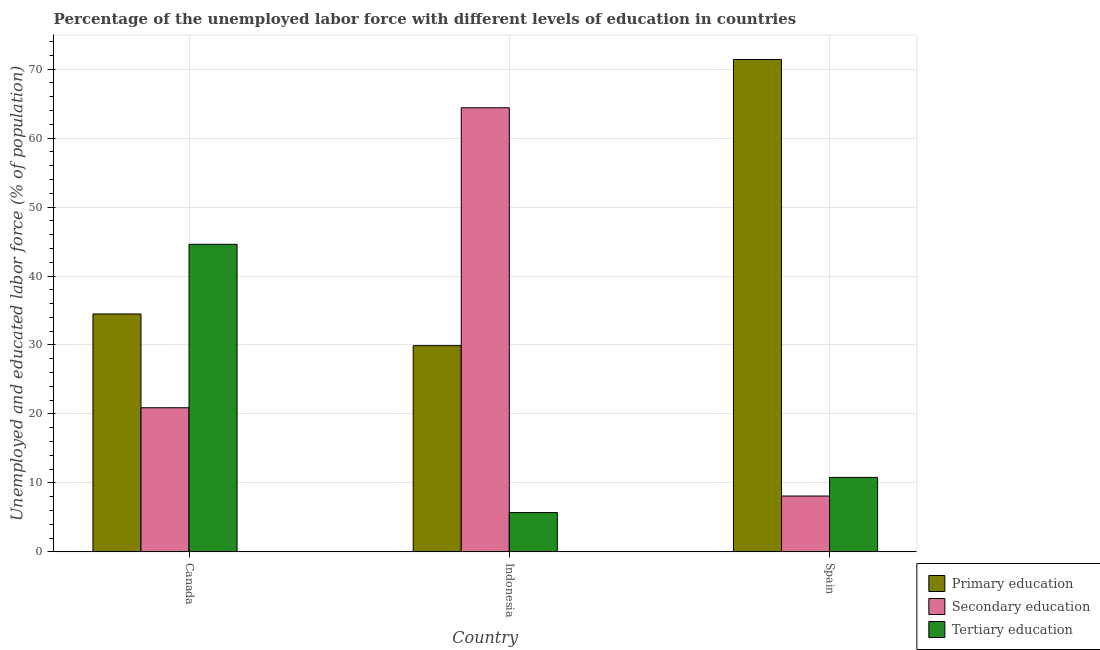How many different coloured bars are there?
Keep it short and to the point. 3. How many groups of bars are there?
Offer a terse response. 3. Are the number of bars on each tick of the X-axis equal?
Ensure brevity in your answer.  Yes. How many bars are there on the 1st tick from the left?
Offer a very short reply. 3. How many bars are there on the 1st tick from the right?
Ensure brevity in your answer.  3. What is the label of the 2nd group of bars from the left?
Provide a short and direct response. Indonesia. What is the percentage of labor force who received tertiary education in Canada?
Keep it short and to the point. 44.6. Across all countries, what is the maximum percentage of labor force who received tertiary education?
Ensure brevity in your answer.  44.6. Across all countries, what is the minimum percentage of labor force who received tertiary education?
Make the answer very short. 5.7. What is the total percentage of labor force who received secondary education in the graph?
Your answer should be very brief. 93.4. What is the difference between the percentage of labor force who received secondary education in Canada and that in Spain?
Your response must be concise. 12.8. What is the difference between the percentage of labor force who received secondary education in Canada and the percentage of labor force who received tertiary education in Indonesia?
Your answer should be very brief. 15.2. What is the average percentage of labor force who received secondary education per country?
Provide a succinct answer. 31.13. What is the difference between the percentage of labor force who received primary education and percentage of labor force who received tertiary education in Indonesia?
Keep it short and to the point. 24.2. In how many countries, is the percentage of labor force who received primary education greater than 36 %?
Your answer should be compact. 1. What is the ratio of the percentage of labor force who received tertiary education in Indonesia to that in Spain?
Your response must be concise. 0.53. Is the difference between the percentage of labor force who received secondary education in Canada and Indonesia greater than the difference between the percentage of labor force who received primary education in Canada and Indonesia?
Offer a terse response. No. What is the difference between the highest and the second highest percentage of labor force who received tertiary education?
Keep it short and to the point. 33.8. What is the difference between the highest and the lowest percentage of labor force who received secondary education?
Your answer should be compact. 56.3. Is the sum of the percentage of labor force who received secondary education in Canada and Spain greater than the maximum percentage of labor force who received tertiary education across all countries?
Offer a terse response. No. What does the 3rd bar from the left in Canada represents?
Provide a short and direct response. Tertiary education. What does the 1st bar from the right in Spain represents?
Offer a very short reply. Tertiary education. How many countries are there in the graph?
Your answer should be compact. 3. Does the graph contain any zero values?
Your answer should be very brief. No. Where does the legend appear in the graph?
Keep it short and to the point. Bottom right. What is the title of the graph?
Your answer should be compact. Percentage of the unemployed labor force with different levels of education in countries. Does "Maunufacturing" appear as one of the legend labels in the graph?
Give a very brief answer. No. What is the label or title of the X-axis?
Your response must be concise. Country. What is the label or title of the Y-axis?
Your answer should be very brief. Unemployed and educated labor force (% of population). What is the Unemployed and educated labor force (% of population) of Primary education in Canada?
Provide a short and direct response. 34.5. What is the Unemployed and educated labor force (% of population) of Secondary education in Canada?
Give a very brief answer. 20.9. What is the Unemployed and educated labor force (% of population) in Tertiary education in Canada?
Make the answer very short. 44.6. What is the Unemployed and educated labor force (% of population) of Primary education in Indonesia?
Your answer should be very brief. 29.9. What is the Unemployed and educated labor force (% of population) in Secondary education in Indonesia?
Your answer should be very brief. 64.4. What is the Unemployed and educated labor force (% of population) in Tertiary education in Indonesia?
Ensure brevity in your answer.  5.7. What is the Unemployed and educated labor force (% of population) in Primary education in Spain?
Provide a short and direct response. 71.4. What is the Unemployed and educated labor force (% of population) in Secondary education in Spain?
Keep it short and to the point. 8.1. What is the Unemployed and educated labor force (% of population) in Tertiary education in Spain?
Provide a succinct answer. 10.8. Across all countries, what is the maximum Unemployed and educated labor force (% of population) in Primary education?
Provide a succinct answer. 71.4. Across all countries, what is the maximum Unemployed and educated labor force (% of population) of Secondary education?
Provide a succinct answer. 64.4. Across all countries, what is the maximum Unemployed and educated labor force (% of population) in Tertiary education?
Offer a terse response. 44.6. Across all countries, what is the minimum Unemployed and educated labor force (% of population) of Primary education?
Ensure brevity in your answer.  29.9. Across all countries, what is the minimum Unemployed and educated labor force (% of population) in Secondary education?
Provide a short and direct response. 8.1. Across all countries, what is the minimum Unemployed and educated labor force (% of population) in Tertiary education?
Give a very brief answer. 5.7. What is the total Unemployed and educated labor force (% of population) in Primary education in the graph?
Your answer should be compact. 135.8. What is the total Unemployed and educated labor force (% of population) of Secondary education in the graph?
Make the answer very short. 93.4. What is the total Unemployed and educated labor force (% of population) in Tertiary education in the graph?
Ensure brevity in your answer.  61.1. What is the difference between the Unemployed and educated labor force (% of population) of Primary education in Canada and that in Indonesia?
Offer a terse response. 4.6. What is the difference between the Unemployed and educated labor force (% of population) in Secondary education in Canada and that in Indonesia?
Your response must be concise. -43.5. What is the difference between the Unemployed and educated labor force (% of population) in Tertiary education in Canada and that in Indonesia?
Keep it short and to the point. 38.9. What is the difference between the Unemployed and educated labor force (% of population) in Primary education in Canada and that in Spain?
Provide a short and direct response. -36.9. What is the difference between the Unemployed and educated labor force (% of population) of Tertiary education in Canada and that in Spain?
Offer a very short reply. 33.8. What is the difference between the Unemployed and educated labor force (% of population) in Primary education in Indonesia and that in Spain?
Your answer should be very brief. -41.5. What is the difference between the Unemployed and educated labor force (% of population) in Secondary education in Indonesia and that in Spain?
Give a very brief answer. 56.3. What is the difference between the Unemployed and educated labor force (% of population) of Tertiary education in Indonesia and that in Spain?
Your answer should be compact. -5.1. What is the difference between the Unemployed and educated labor force (% of population) of Primary education in Canada and the Unemployed and educated labor force (% of population) of Secondary education in Indonesia?
Keep it short and to the point. -29.9. What is the difference between the Unemployed and educated labor force (% of population) of Primary education in Canada and the Unemployed and educated labor force (% of population) of Tertiary education in Indonesia?
Give a very brief answer. 28.8. What is the difference between the Unemployed and educated labor force (% of population) of Secondary education in Canada and the Unemployed and educated labor force (% of population) of Tertiary education in Indonesia?
Your response must be concise. 15.2. What is the difference between the Unemployed and educated labor force (% of population) of Primary education in Canada and the Unemployed and educated labor force (% of population) of Secondary education in Spain?
Your answer should be very brief. 26.4. What is the difference between the Unemployed and educated labor force (% of population) in Primary education in Canada and the Unemployed and educated labor force (% of population) in Tertiary education in Spain?
Your answer should be compact. 23.7. What is the difference between the Unemployed and educated labor force (% of population) of Primary education in Indonesia and the Unemployed and educated labor force (% of population) of Secondary education in Spain?
Your answer should be compact. 21.8. What is the difference between the Unemployed and educated labor force (% of population) of Secondary education in Indonesia and the Unemployed and educated labor force (% of population) of Tertiary education in Spain?
Make the answer very short. 53.6. What is the average Unemployed and educated labor force (% of population) in Primary education per country?
Your answer should be compact. 45.27. What is the average Unemployed and educated labor force (% of population) of Secondary education per country?
Provide a short and direct response. 31.13. What is the average Unemployed and educated labor force (% of population) in Tertiary education per country?
Offer a very short reply. 20.37. What is the difference between the Unemployed and educated labor force (% of population) in Primary education and Unemployed and educated labor force (% of population) in Secondary education in Canada?
Provide a short and direct response. 13.6. What is the difference between the Unemployed and educated labor force (% of population) in Primary education and Unemployed and educated labor force (% of population) in Tertiary education in Canada?
Provide a succinct answer. -10.1. What is the difference between the Unemployed and educated labor force (% of population) in Secondary education and Unemployed and educated labor force (% of population) in Tertiary education in Canada?
Ensure brevity in your answer.  -23.7. What is the difference between the Unemployed and educated labor force (% of population) in Primary education and Unemployed and educated labor force (% of population) in Secondary education in Indonesia?
Offer a very short reply. -34.5. What is the difference between the Unemployed and educated labor force (% of population) in Primary education and Unemployed and educated labor force (% of population) in Tertiary education in Indonesia?
Ensure brevity in your answer.  24.2. What is the difference between the Unemployed and educated labor force (% of population) in Secondary education and Unemployed and educated labor force (% of population) in Tertiary education in Indonesia?
Keep it short and to the point. 58.7. What is the difference between the Unemployed and educated labor force (% of population) in Primary education and Unemployed and educated labor force (% of population) in Secondary education in Spain?
Provide a short and direct response. 63.3. What is the difference between the Unemployed and educated labor force (% of population) of Primary education and Unemployed and educated labor force (% of population) of Tertiary education in Spain?
Offer a terse response. 60.6. What is the difference between the Unemployed and educated labor force (% of population) in Secondary education and Unemployed and educated labor force (% of population) in Tertiary education in Spain?
Provide a succinct answer. -2.7. What is the ratio of the Unemployed and educated labor force (% of population) in Primary education in Canada to that in Indonesia?
Ensure brevity in your answer.  1.15. What is the ratio of the Unemployed and educated labor force (% of population) of Secondary education in Canada to that in Indonesia?
Offer a very short reply. 0.32. What is the ratio of the Unemployed and educated labor force (% of population) in Tertiary education in Canada to that in Indonesia?
Provide a succinct answer. 7.82. What is the ratio of the Unemployed and educated labor force (% of population) in Primary education in Canada to that in Spain?
Your answer should be very brief. 0.48. What is the ratio of the Unemployed and educated labor force (% of population) in Secondary education in Canada to that in Spain?
Give a very brief answer. 2.58. What is the ratio of the Unemployed and educated labor force (% of population) of Tertiary education in Canada to that in Spain?
Offer a terse response. 4.13. What is the ratio of the Unemployed and educated labor force (% of population) of Primary education in Indonesia to that in Spain?
Provide a short and direct response. 0.42. What is the ratio of the Unemployed and educated labor force (% of population) in Secondary education in Indonesia to that in Spain?
Make the answer very short. 7.95. What is the ratio of the Unemployed and educated labor force (% of population) of Tertiary education in Indonesia to that in Spain?
Offer a very short reply. 0.53. What is the difference between the highest and the second highest Unemployed and educated labor force (% of population) in Primary education?
Give a very brief answer. 36.9. What is the difference between the highest and the second highest Unemployed and educated labor force (% of population) of Secondary education?
Give a very brief answer. 43.5. What is the difference between the highest and the second highest Unemployed and educated labor force (% of population) of Tertiary education?
Provide a succinct answer. 33.8. What is the difference between the highest and the lowest Unemployed and educated labor force (% of population) in Primary education?
Provide a short and direct response. 41.5. What is the difference between the highest and the lowest Unemployed and educated labor force (% of population) of Secondary education?
Provide a succinct answer. 56.3. What is the difference between the highest and the lowest Unemployed and educated labor force (% of population) of Tertiary education?
Provide a succinct answer. 38.9. 